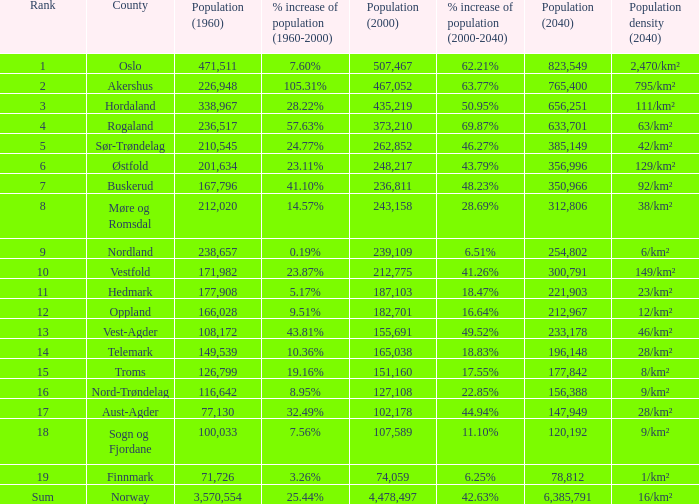What was the population of a county in 2040 that had a population less than 108,172 in 2000 and less than 107,589 in 1960? 2.0. 